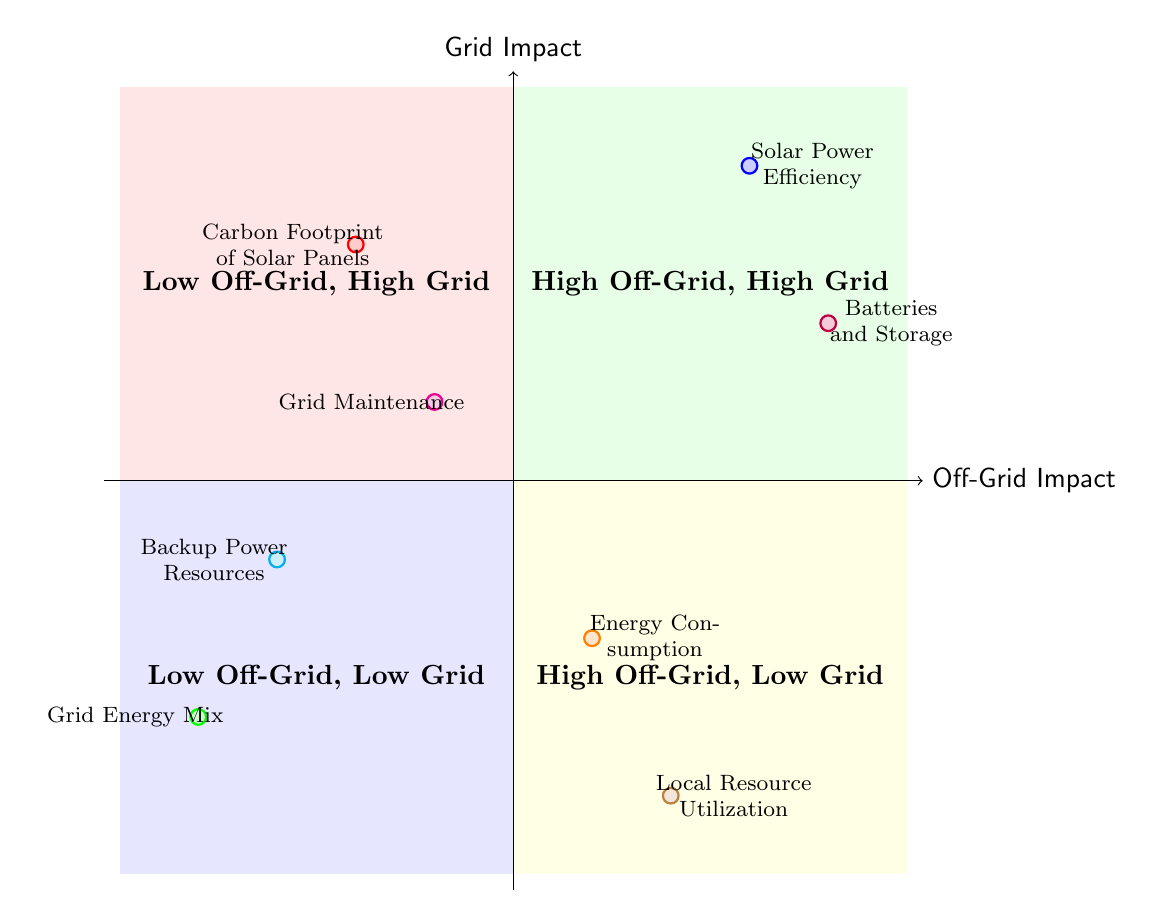What is the node representing the highest off-grid impact? The highest off-grid impact is represented by the node "Solar Power Efficiency," which is positioned in the top right quadrant of the diagram.
Answer: Solar Power Efficiency Which node indicates a low off-grid and high grid impact? The node that indicates low off-grid and high grid impact is "Grid Energy Mix," located in the bottom left quadrant of the diagram.
Answer: Grid Energy Mix How many nodes are plotted in the diagram? The diagram contains a total of eight nodes, each representing different elements related to off-grid living and grid dependency.
Answer: 8 What is the relationship between "Batteries and Storage" and "Carbon Footprint of Solar Panels"? "Batteries and Storage" is positioned high on the off-grid impact scale while "Carbon Footprint of Solar Panels" is positioned low on the same scale, indicating that battery production impacts are acknowledged even when solar is used efficiently.
Answer: Different impacts Which element is associated with the highest grid impact? "Grid Maintenance" is located in the top left quadrant, indicating it is associated with the highest grid impact according to the diagram.
Answer: Grid Maintenance How does "Local Resource Utilization" relate to "Energy Consumption"? "Local Resource Utilization" is positioned in the bottom right quadrant and "Energy Consumption" is in the bottom left, showing that local resources can potentially lead to lower energy consumption; contrasting their positions indicates a relationship where local sourcing influences consumption.
Answer: Indirect relationship Is there any overlap between off-grid and grid dependency impacts in this diagram? There is no overlap illustrated in the diagram, as each of the quadrants distinctly categorizes impacts based on their off-grid and grid positions, indicating they are mutually exclusive categories.
Answer: No overlap What color represents the "Backup Power Resources" in the diagram? The "Backup Power Resources" node is represented in cyan, indicating its position in relation to other elements in the diagram.
Answer: Cyan 